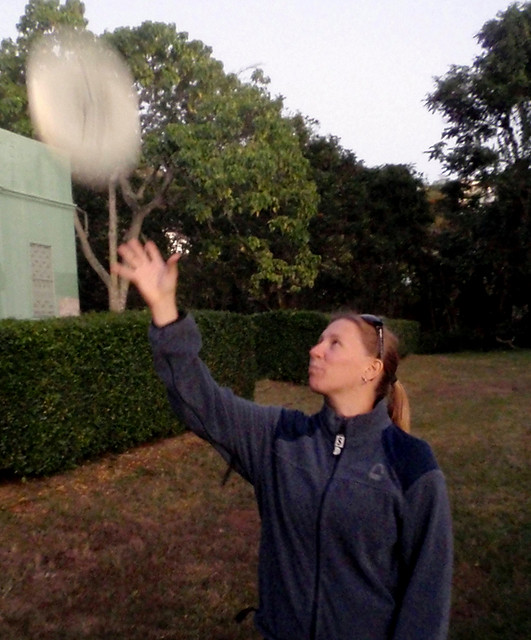<image>What holds up her pants? I don't know what holds up her pants. It could be a belt or the waistband of the pants. What holds up her pants? I don't know what holds up her pants. But it can be seen a belt. 